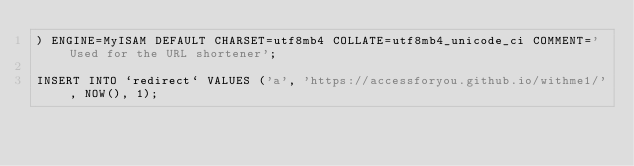<code> <loc_0><loc_0><loc_500><loc_500><_SQL_>) ENGINE=MyISAM DEFAULT CHARSET=utf8mb4 COLLATE=utf8mb4_unicode_ci COMMENT='Used for the URL shortener';

INSERT INTO `redirect` VALUES ('a', 'https://accessforyou.github.io/withme1/', NOW(), 1);
</code> 